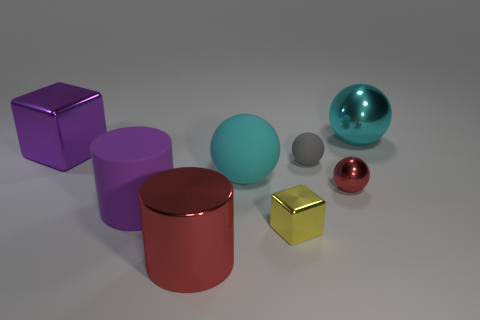Subtract all blue cylinders. Subtract all green spheres. How many cylinders are left? 2 Add 2 large gray shiny cylinders. How many objects exist? 10 Subtract all blocks. How many objects are left? 6 Add 3 big purple rubber objects. How many big purple rubber objects exist? 4 Subtract 0 blue blocks. How many objects are left? 8 Subtract all red metallic cylinders. Subtract all small shiny objects. How many objects are left? 5 Add 4 tiny red metallic things. How many tiny red metallic things are left? 5 